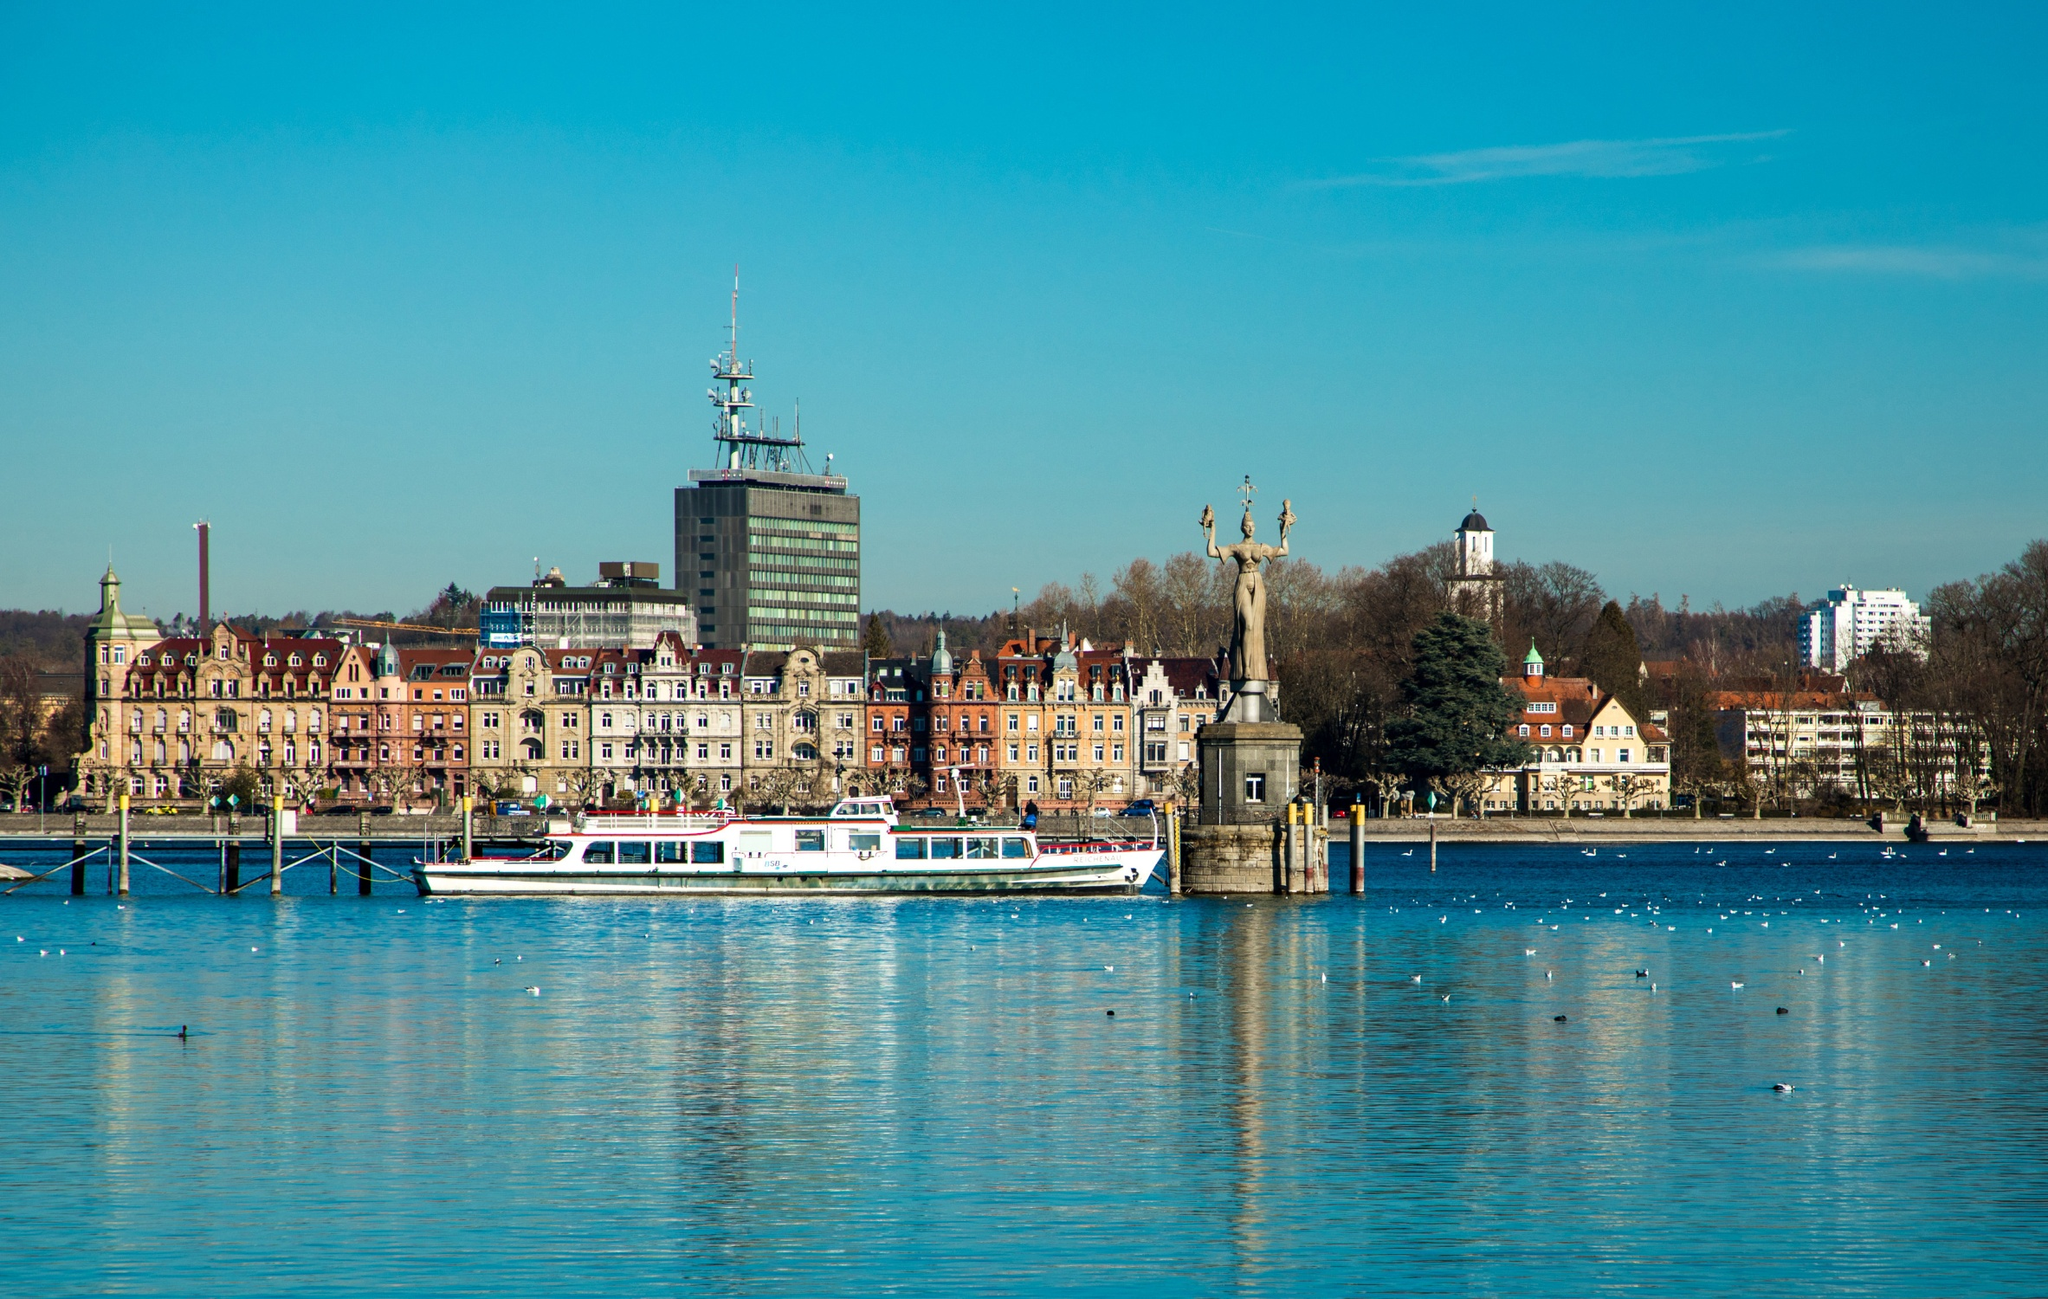Analyze the image in a comprehensive and detailed manner. The image captures the picturesque and tranquil beauty of Constance Harbour in Germany. From the water, we are provided with a stunning panoramic view of the cityscape that showcases an enticing blend of historical and modern architecture. The sky is a vivid blue, seamlessly merging with the rich blue of the water, creating a serene and harmonious backdrop. The city is characterized by its charming old buildings with colorful facades, interspersed with more contemporary structures. A pristine white boat is seen gliding gracefully across the water, infusing the scene with a sense of liveliness and motion. On the right side stands a significant historical monument: a statue of a woman holding what appears to be a shield, likely adding cultural and historical context to the area. Predominantly, the color palette of the image is composed of blues, whites, and earthy browns, which together render a visually appealing and calming atmosphere. Not related to the visual aspect, the landmark identifier 'sa_15454' interestingly corresponds to a Cisco product, which is unrelated to the scene depicted. This image of Constance Harbour eloquently encapsulates the harmonious blend of nature, history, and modernity. 